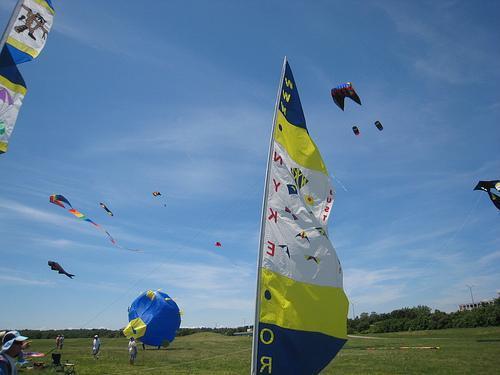How many kites are there?
Give a very brief answer. 3. 